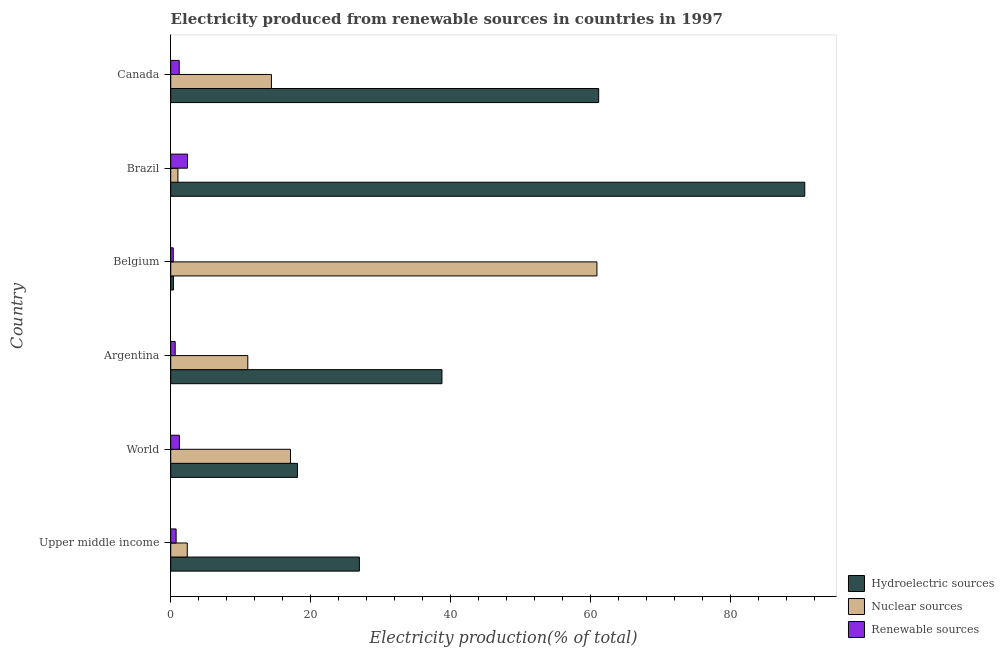How many groups of bars are there?
Offer a terse response. 6. Are the number of bars on each tick of the Y-axis equal?
Keep it short and to the point. Yes. How many bars are there on the 3rd tick from the bottom?
Ensure brevity in your answer.  3. What is the percentage of electricity produced by nuclear sources in Belgium?
Give a very brief answer. 60.89. Across all countries, what is the maximum percentage of electricity produced by renewable sources?
Give a very brief answer. 2.4. Across all countries, what is the minimum percentage of electricity produced by renewable sources?
Your answer should be very brief. 0.36. In which country was the percentage of electricity produced by hydroelectric sources minimum?
Your answer should be very brief. Belgium. What is the total percentage of electricity produced by nuclear sources in the graph?
Make the answer very short. 106.79. What is the difference between the percentage of electricity produced by nuclear sources in Canada and that in World?
Give a very brief answer. -2.72. What is the difference between the percentage of electricity produced by nuclear sources in World and the percentage of electricity produced by renewable sources in Brazil?
Keep it short and to the point. 14.71. What is the average percentage of electricity produced by hydroelectric sources per country?
Give a very brief answer. 39.32. What is the difference between the percentage of electricity produced by nuclear sources and percentage of electricity produced by renewable sources in Brazil?
Offer a terse response. -1.37. Is the percentage of electricity produced by renewable sources in Upper middle income less than that in World?
Offer a terse response. Yes. What is the difference between the highest and the second highest percentage of electricity produced by nuclear sources?
Make the answer very short. 43.78. What is the difference between the highest and the lowest percentage of electricity produced by nuclear sources?
Provide a short and direct response. 59.86. Is the sum of the percentage of electricity produced by hydroelectric sources in Argentina and Belgium greater than the maximum percentage of electricity produced by renewable sources across all countries?
Keep it short and to the point. Yes. What does the 1st bar from the top in Canada represents?
Make the answer very short. Renewable sources. What does the 1st bar from the bottom in World represents?
Offer a very short reply. Hydroelectric sources. How many bars are there?
Your answer should be compact. 18. Are all the bars in the graph horizontal?
Your answer should be very brief. Yes. How many countries are there in the graph?
Offer a very short reply. 6. Where does the legend appear in the graph?
Your answer should be compact. Bottom right. How many legend labels are there?
Your response must be concise. 3. How are the legend labels stacked?
Provide a succinct answer. Vertical. What is the title of the graph?
Ensure brevity in your answer.  Electricity produced from renewable sources in countries in 1997. What is the label or title of the Y-axis?
Your answer should be very brief. Country. What is the Electricity production(% of total) of Hydroelectric sources in Upper middle income?
Offer a very short reply. 26.95. What is the Electricity production(% of total) in Nuclear sources in Upper middle income?
Your answer should be compact. 2.36. What is the Electricity production(% of total) of Renewable sources in Upper middle income?
Your answer should be compact. 0.77. What is the Electricity production(% of total) in Hydroelectric sources in World?
Your answer should be very brief. 18.11. What is the Electricity production(% of total) of Nuclear sources in World?
Keep it short and to the point. 17.11. What is the Electricity production(% of total) of Renewable sources in World?
Your answer should be very brief. 1.24. What is the Electricity production(% of total) of Hydroelectric sources in Argentina?
Offer a terse response. 38.75. What is the Electricity production(% of total) in Nuclear sources in Argentina?
Your response must be concise. 11.01. What is the Electricity production(% of total) of Renewable sources in Argentina?
Your answer should be very brief. 0.64. What is the Electricity production(% of total) of Hydroelectric sources in Belgium?
Give a very brief answer. 0.39. What is the Electricity production(% of total) in Nuclear sources in Belgium?
Ensure brevity in your answer.  60.89. What is the Electricity production(% of total) in Renewable sources in Belgium?
Provide a short and direct response. 0.36. What is the Electricity production(% of total) of Hydroelectric sources in Brazil?
Give a very brief answer. 90.58. What is the Electricity production(% of total) in Nuclear sources in Brazil?
Keep it short and to the point. 1.03. What is the Electricity production(% of total) in Renewable sources in Brazil?
Your answer should be very brief. 2.4. What is the Electricity production(% of total) in Hydroelectric sources in Canada?
Your answer should be very brief. 61.14. What is the Electricity production(% of total) of Nuclear sources in Canada?
Your response must be concise. 14.39. What is the Electricity production(% of total) of Renewable sources in Canada?
Offer a very short reply. 1.21. Across all countries, what is the maximum Electricity production(% of total) in Hydroelectric sources?
Your answer should be compact. 90.58. Across all countries, what is the maximum Electricity production(% of total) of Nuclear sources?
Provide a succinct answer. 60.89. Across all countries, what is the maximum Electricity production(% of total) of Renewable sources?
Provide a short and direct response. 2.4. Across all countries, what is the minimum Electricity production(% of total) of Hydroelectric sources?
Your response must be concise. 0.39. Across all countries, what is the minimum Electricity production(% of total) of Nuclear sources?
Keep it short and to the point. 1.03. Across all countries, what is the minimum Electricity production(% of total) in Renewable sources?
Keep it short and to the point. 0.36. What is the total Electricity production(% of total) of Hydroelectric sources in the graph?
Provide a short and direct response. 235.92. What is the total Electricity production(% of total) of Nuclear sources in the graph?
Your answer should be compact. 106.79. What is the total Electricity production(% of total) in Renewable sources in the graph?
Your answer should be very brief. 6.62. What is the difference between the Electricity production(% of total) in Hydroelectric sources in Upper middle income and that in World?
Your answer should be compact. 8.85. What is the difference between the Electricity production(% of total) in Nuclear sources in Upper middle income and that in World?
Provide a succinct answer. -14.74. What is the difference between the Electricity production(% of total) in Renewable sources in Upper middle income and that in World?
Offer a terse response. -0.47. What is the difference between the Electricity production(% of total) in Hydroelectric sources in Upper middle income and that in Argentina?
Give a very brief answer. -11.8. What is the difference between the Electricity production(% of total) in Nuclear sources in Upper middle income and that in Argentina?
Your answer should be very brief. -8.65. What is the difference between the Electricity production(% of total) of Renewable sources in Upper middle income and that in Argentina?
Offer a terse response. 0.13. What is the difference between the Electricity production(% of total) of Hydroelectric sources in Upper middle income and that in Belgium?
Make the answer very short. 26.56. What is the difference between the Electricity production(% of total) in Nuclear sources in Upper middle income and that in Belgium?
Your response must be concise. -58.52. What is the difference between the Electricity production(% of total) of Renewable sources in Upper middle income and that in Belgium?
Ensure brevity in your answer.  0.41. What is the difference between the Electricity production(% of total) of Hydroelectric sources in Upper middle income and that in Brazil?
Provide a short and direct response. -63.63. What is the difference between the Electricity production(% of total) in Nuclear sources in Upper middle income and that in Brazil?
Give a very brief answer. 1.34. What is the difference between the Electricity production(% of total) of Renewable sources in Upper middle income and that in Brazil?
Ensure brevity in your answer.  -1.63. What is the difference between the Electricity production(% of total) in Hydroelectric sources in Upper middle income and that in Canada?
Give a very brief answer. -34.19. What is the difference between the Electricity production(% of total) of Nuclear sources in Upper middle income and that in Canada?
Make the answer very short. -12.02. What is the difference between the Electricity production(% of total) of Renewable sources in Upper middle income and that in Canada?
Offer a very short reply. -0.44. What is the difference between the Electricity production(% of total) of Hydroelectric sources in World and that in Argentina?
Offer a very short reply. -20.64. What is the difference between the Electricity production(% of total) of Nuclear sources in World and that in Argentina?
Provide a short and direct response. 6.1. What is the difference between the Electricity production(% of total) in Renewable sources in World and that in Argentina?
Offer a terse response. 0.6. What is the difference between the Electricity production(% of total) in Hydroelectric sources in World and that in Belgium?
Keep it short and to the point. 17.71. What is the difference between the Electricity production(% of total) of Nuclear sources in World and that in Belgium?
Your answer should be compact. -43.78. What is the difference between the Electricity production(% of total) of Renewable sources in World and that in Belgium?
Make the answer very short. 0.88. What is the difference between the Electricity production(% of total) in Hydroelectric sources in World and that in Brazil?
Offer a terse response. -72.48. What is the difference between the Electricity production(% of total) of Nuclear sources in World and that in Brazil?
Provide a short and direct response. 16.08. What is the difference between the Electricity production(% of total) of Renewable sources in World and that in Brazil?
Your answer should be compact. -1.16. What is the difference between the Electricity production(% of total) of Hydroelectric sources in World and that in Canada?
Give a very brief answer. -43.03. What is the difference between the Electricity production(% of total) in Nuclear sources in World and that in Canada?
Keep it short and to the point. 2.72. What is the difference between the Electricity production(% of total) of Renewable sources in World and that in Canada?
Give a very brief answer. 0.03. What is the difference between the Electricity production(% of total) of Hydroelectric sources in Argentina and that in Belgium?
Your response must be concise. 38.36. What is the difference between the Electricity production(% of total) of Nuclear sources in Argentina and that in Belgium?
Your answer should be compact. -49.88. What is the difference between the Electricity production(% of total) in Renewable sources in Argentina and that in Belgium?
Ensure brevity in your answer.  0.27. What is the difference between the Electricity production(% of total) in Hydroelectric sources in Argentina and that in Brazil?
Your response must be concise. -51.83. What is the difference between the Electricity production(% of total) in Nuclear sources in Argentina and that in Brazil?
Your response must be concise. 9.98. What is the difference between the Electricity production(% of total) of Renewable sources in Argentina and that in Brazil?
Provide a short and direct response. -1.76. What is the difference between the Electricity production(% of total) of Hydroelectric sources in Argentina and that in Canada?
Your response must be concise. -22.39. What is the difference between the Electricity production(% of total) of Nuclear sources in Argentina and that in Canada?
Give a very brief answer. -3.38. What is the difference between the Electricity production(% of total) of Renewable sources in Argentina and that in Canada?
Make the answer very short. -0.57. What is the difference between the Electricity production(% of total) of Hydroelectric sources in Belgium and that in Brazil?
Your response must be concise. -90.19. What is the difference between the Electricity production(% of total) in Nuclear sources in Belgium and that in Brazil?
Make the answer very short. 59.86. What is the difference between the Electricity production(% of total) in Renewable sources in Belgium and that in Brazil?
Offer a very short reply. -2.03. What is the difference between the Electricity production(% of total) of Hydroelectric sources in Belgium and that in Canada?
Offer a very short reply. -60.75. What is the difference between the Electricity production(% of total) of Nuclear sources in Belgium and that in Canada?
Keep it short and to the point. 46.5. What is the difference between the Electricity production(% of total) of Renewable sources in Belgium and that in Canada?
Ensure brevity in your answer.  -0.85. What is the difference between the Electricity production(% of total) in Hydroelectric sources in Brazil and that in Canada?
Your answer should be compact. 29.44. What is the difference between the Electricity production(% of total) of Nuclear sources in Brazil and that in Canada?
Keep it short and to the point. -13.36. What is the difference between the Electricity production(% of total) in Renewable sources in Brazil and that in Canada?
Make the answer very short. 1.19. What is the difference between the Electricity production(% of total) of Hydroelectric sources in Upper middle income and the Electricity production(% of total) of Nuclear sources in World?
Offer a very short reply. 9.85. What is the difference between the Electricity production(% of total) of Hydroelectric sources in Upper middle income and the Electricity production(% of total) of Renewable sources in World?
Give a very brief answer. 25.71. What is the difference between the Electricity production(% of total) of Nuclear sources in Upper middle income and the Electricity production(% of total) of Renewable sources in World?
Your response must be concise. 1.12. What is the difference between the Electricity production(% of total) in Hydroelectric sources in Upper middle income and the Electricity production(% of total) in Nuclear sources in Argentina?
Offer a very short reply. 15.94. What is the difference between the Electricity production(% of total) of Hydroelectric sources in Upper middle income and the Electricity production(% of total) of Renewable sources in Argentina?
Give a very brief answer. 26.31. What is the difference between the Electricity production(% of total) in Nuclear sources in Upper middle income and the Electricity production(% of total) in Renewable sources in Argentina?
Make the answer very short. 1.73. What is the difference between the Electricity production(% of total) in Hydroelectric sources in Upper middle income and the Electricity production(% of total) in Nuclear sources in Belgium?
Make the answer very short. -33.94. What is the difference between the Electricity production(% of total) in Hydroelectric sources in Upper middle income and the Electricity production(% of total) in Renewable sources in Belgium?
Your answer should be compact. 26.59. What is the difference between the Electricity production(% of total) of Nuclear sources in Upper middle income and the Electricity production(% of total) of Renewable sources in Belgium?
Provide a short and direct response. 2. What is the difference between the Electricity production(% of total) in Hydroelectric sources in Upper middle income and the Electricity production(% of total) in Nuclear sources in Brazil?
Keep it short and to the point. 25.92. What is the difference between the Electricity production(% of total) in Hydroelectric sources in Upper middle income and the Electricity production(% of total) in Renewable sources in Brazil?
Your response must be concise. 24.56. What is the difference between the Electricity production(% of total) in Nuclear sources in Upper middle income and the Electricity production(% of total) in Renewable sources in Brazil?
Your answer should be compact. -0.03. What is the difference between the Electricity production(% of total) of Hydroelectric sources in Upper middle income and the Electricity production(% of total) of Nuclear sources in Canada?
Give a very brief answer. 12.56. What is the difference between the Electricity production(% of total) of Hydroelectric sources in Upper middle income and the Electricity production(% of total) of Renewable sources in Canada?
Your answer should be compact. 25.74. What is the difference between the Electricity production(% of total) of Nuclear sources in Upper middle income and the Electricity production(% of total) of Renewable sources in Canada?
Keep it short and to the point. 1.15. What is the difference between the Electricity production(% of total) in Hydroelectric sources in World and the Electricity production(% of total) in Nuclear sources in Argentina?
Your answer should be compact. 7.09. What is the difference between the Electricity production(% of total) in Hydroelectric sources in World and the Electricity production(% of total) in Renewable sources in Argentina?
Offer a very short reply. 17.47. What is the difference between the Electricity production(% of total) in Nuclear sources in World and the Electricity production(% of total) in Renewable sources in Argentina?
Your answer should be very brief. 16.47. What is the difference between the Electricity production(% of total) in Hydroelectric sources in World and the Electricity production(% of total) in Nuclear sources in Belgium?
Keep it short and to the point. -42.78. What is the difference between the Electricity production(% of total) of Hydroelectric sources in World and the Electricity production(% of total) of Renewable sources in Belgium?
Offer a very short reply. 17.74. What is the difference between the Electricity production(% of total) in Nuclear sources in World and the Electricity production(% of total) in Renewable sources in Belgium?
Give a very brief answer. 16.74. What is the difference between the Electricity production(% of total) in Hydroelectric sources in World and the Electricity production(% of total) in Nuclear sources in Brazil?
Ensure brevity in your answer.  17.08. What is the difference between the Electricity production(% of total) of Hydroelectric sources in World and the Electricity production(% of total) of Renewable sources in Brazil?
Your response must be concise. 15.71. What is the difference between the Electricity production(% of total) in Nuclear sources in World and the Electricity production(% of total) in Renewable sources in Brazil?
Give a very brief answer. 14.71. What is the difference between the Electricity production(% of total) of Hydroelectric sources in World and the Electricity production(% of total) of Nuclear sources in Canada?
Offer a very short reply. 3.72. What is the difference between the Electricity production(% of total) of Hydroelectric sources in World and the Electricity production(% of total) of Renewable sources in Canada?
Provide a short and direct response. 16.89. What is the difference between the Electricity production(% of total) of Nuclear sources in World and the Electricity production(% of total) of Renewable sources in Canada?
Ensure brevity in your answer.  15.9. What is the difference between the Electricity production(% of total) of Hydroelectric sources in Argentina and the Electricity production(% of total) of Nuclear sources in Belgium?
Provide a succinct answer. -22.14. What is the difference between the Electricity production(% of total) in Hydroelectric sources in Argentina and the Electricity production(% of total) in Renewable sources in Belgium?
Make the answer very short. 38.39. What is the difference between the Electricity production(% of total) in Nuclear sources in Argentina and the Electricity production(% of total) in Renewable sources in Belgium?
Ensure brevity in your answer.  10.65. What is the difference between the Electricity production(% of total) in Hydroelectric sources in Argentina and the Electricity production(% of total) in Nuclear sources in Brazil?
Your response must be concise. 37.72. What is the difference between the Electricity production(% of total) in Hydroelectric sources in Argentina and the Electricity production(% of total) in Renewable sources in Brazil?
Offer a very short reply. 36.35. What is the difference between the Electricity production(% of total) in Nuclear sources in Argentina and the Electricity production(% of total) in Renewable sources in Brazil?
Your answer should be very brief. 8.61. What is the difference between the Electricity production(% of total) in Hydroelectric sources in Argentina and the Electricity production(% of total) in Nuclear sources in Canada?
Your answer should be compact. 24.36. What is the difference between the Electricity production(% of total) of Hydroelectric sources in Argentina and the Electricity production(% of total) of Renewable sources in Canada?
Your answer should be very brief. 37.54. What is the difference between the Electricity production(% of total) in Nuclear sources in Argentina and the Electricity production(% of total) in Renewable sources in Canada?
Provide a succinct answer. 9.8. What is the difference between the Electricity production(% of total) in Hydroelectric sources in Belgium and the Electricity production(% of total) in Nuclear sources in Brazil?
Make the answer very short. -0.64. What is the difference between the Electricity production(% of total) in Hydroelectric sources in Belgium and the Electricity production(% of total) in Renewable sources in Brazil?
Ensure brevity in your answer.  -2.01. What is the difference between the Electricity production(% of total) in Nuclear sources in Belgium and the Electricity production(% of total) in Renewable sources in Brazil?
Your answer should be compact. 58.49. What is the difference between the Electricity production(% of total) of Hydroelectric sources in Belgium and the Electricity production(% of total) of Nuclear sources in Canada?
Keep it short and to the point. -14. What is the difference between the Electricity production(% of total) of Hydroelectric sources in Belgium and the Electricity production(% of total) of Renewable sources in Canada?
Your answer should be very brief. -0.82. What is the difference between the Electricity production(% of total) of Nuclear sources in Belgium and the Electricity production(% of total) of Renewable sources in Canada?
Ensure brevity in your answer.  59.68. What is the difference between the Electricity production(% of total) in Hydroelectric sources in Brazil and the Electricity production(% of total) in Nuclear sources in Canada?
Offer a very short reply. 76.19. What is the difference between the Electricity production(% of total) of Hydroelectric sources in Brazil and the Electricity production(% of total) of Renewable sources in Canada?
Your answer should be compact. 89.37. What is the difference between the Electricity production(% of total) in Nuclear sources in Brazil and the Electricity production(% of total) in Renewable sources in Canada?
Give a very brief answer. -0.18. What is the average Electricity production(% of total) in Hydroelectric sources per country?
Give a very brief answer. 39.32. What is the average Electricity production(% of total) of Nuclear sources per country?
Offer a very short reply. 17.8. What is the average Electricity production(% of total) in Renewable sources per country?
Offer a very short reply. 1.1. What is the difference between the Electricity production(% of total) in Hydroelectric sources and Electricity production(% of total) in Nuclear sources in Upper middle income?
Ensure brevity in your answer.  24.59. What is the difference between the Electricity production(% of total) of Hydroelectric sources and Electricity production(% of total) of Renewable sources in Upper middle income?
Offer a terse response. 26.18. What is the difference between the Electricity production(% of total) in Nuclear sources and Electricity production(% of total) in Renewable sources in Upper middle income?
Provide a short and direct response. 1.59. What is the difference between the Electricity production(% of total) in Hydroelectric sources and Electricity production(% of total) in Nuclear sources in World?
Your answer should be very brief. 1. What is the difference between the Electricity production(% of total) of Hydroelectric sources and Electricity production(% of total) of Renewable sources in World?
Provide a short and direct response. 16.87. What is the difference between the Electricity production(% of total) in Nuclear sources and Electricity production(% of total) in Renewable sources in World?
Offer a terse response. 15.87. What is the difference between the Electricity production(% of total) in Hydroelectric sources and Electricity production(% of total) in Nuclear sources in Argentina?
Your answer should be compact. 27.74. What is the difference between the Electricity production(% of total) in Hydroelectric sources and Electricity production(% of total) in Renewable sources in Argentina?
Your answer should be compact. 38.11. What is the difference between the Electricity production(% of total) of Nuclear sources and Electricity production(% of total) of Renewable sources in Argentina?
Offer a terse response. 10.37. What is the difference between the Electricity production(% of total) in Hydroelectric sources and Electricity production(% of total) in Nuclear sources in Belgium?
Ensure brevity in your answer.  -60.5. What is the difference between the Electricity production(% of total) of Hydroelectric sources and Electricity production(% of total) of Renewable sources in Belgium?
Offer a very short reply. 0.03. What is the difference between the Electricity production(% of total) in Nuclear sources and Electricity production(% of total) in Renewable sources in Belgium?
Your response must be concise. 60.52. What is the difference between the Electricity production(% of total) of Hydroelectric sources and Electricity production(% of total) of Nuclear sources in Brazil?
Your answer should be compact. 89.55. What is the difference between the Electricity production(% of total) in Hydroelectric sources and Electricity production(% of total) in Renewable sources in Brazil?
Your response must be concise. 88.18. What is the difference between the Electricity production(% of total) in Nuclear sources and Electricity production(% of total) in Renewable sources in Brazil?
Provide a succinct answer. -1.37. What is the difference between the Electricity production(% of total) of Hydroelectric sources and Electricity production(% of total) of Nuclear sources in Canada?
Ensure brevity in your answer.  46.75. What is the difference between the Electricity production(% of total) in Hydroelectric sources and Electricity production(% of total) in Renewable sources in Canada?
Keep it short and to the point. 59.93. What is the difference between the Electricity production(% of total) in Nuclear sources and Electricity production(% of total) in Renewable sources in Canada?
Keep it short and to the point. 13.18. What is the ratio of the Electricity production(% of total) in Hydroelectric sources in Upper middle income to that in World?
Provide a short and direct response. 1.49. What is the ratio of the Electricity production(% of total) in Nuclear sources in Upper middle income to that in World?
Your response must be concise. 0.14. What is the ratio of the Electricity production(% of total) of Renewable sources in Upper middle income to that in World?
Ensure brevity in your answer.  0.62. What is the ratio of the Electricity production(% of total) in Hydroelectric sources in Upper middle income to that in Argentina?
Your response must be concise. 0.7. What is the ratio of the Electricity production(% of total) of Nuclear sources in Upper middle income to that in Argentina?
Your response must be concise. 0.21. What is the ratio of the Electricity production(% of total) of Renewable sources in Upper middle income to that in Argentina?
Keep it short and to the point. 1.21. What is the ratio of the Electricity production(% of total) in Hydroelectric sources in Upper middle income to that in Belgium?
Your answer should be very brief. 68.8. What is the ratio of the Electricity production(% of total) of Nuclear sources in Upper middle income to that in Belgium?
Offer a terse response. 0.04. What is the ratio of the Electricity production(% of total) in Renewable sources in Upper middle income to that in Belgium?
Make the answer very short. 2.12. What is the ratio of the Electricity production(% of total) in Hydroelectric sources in Upper middle income to that in Brazil?
Provide a succinct answer. 0.3. What is the ratio of the Electricity production(% of total) of Nuclear sources in Upper middle income to that in Brazil?
Your answer should be compact. 2.3. What is the ratio of the Electricity production(% of total) in Renewable sources in Upper middle income to that in Brazil?
Make the answer very short. 0.32. What is the ratio of the Electricity production(% of total) of Hydroelectric sources in Upper middle income to that in Canada?
Provide a succinct answer. 0.44. What is the ratio of the Electricity production(% of total) in Nuclear sources in Upper middle income to that in Canada?
Provide a succinct answer. 0.16. What is the ratio of the Electricity production(% of total) in Renewable sources in Upper middle income to that in Canada?
Provide a short and direct response. 0.64. What is the ratio of the Electricity production(% of total) in Hydroelectric sources in World to that in Argentina?
Your response must be concise. 0.47. What is the ratio of the Electricity production(% of total) in Nuclear sources in World to that in Argentina?
Your response must be concise. 1.55. What is the ratio of the Electricity production(% of total) in Renewable sources in World to that in Argentina?
Offer a very short reply. 1.94. What is the ratio of the Electricity production(% of total) in Hydroelectric sources in World to that in Belgium?
Keep it short and to the point. 46.22. What is the ratio of the Electricity production(% of total) of Nuclear sources in World to that in Belgium?
Give a very brief answer. 0.28. What is the ratio of the Electricity production(% of total) in Renewable sources in World to that in Belgium?
Make the answer very short. 3.41. What is the ratio of the Electricity production(% of total) in Hydroelectric sources in World to that in Brazil?
Provide a short and direct response. 0.2. What is the ratio of the Electricity production(% of total) of Nuclear sources in World to that in Brazil?
Your answer should be compact. 16.63. What is the ratio of the Electricity production(% of total) in Renewable sources in World to that in Brazil?
Make the answer very short. 0.52. What is the ratio of the Electricity production(% of total) in Hydroelectric sources in World to that in Canada?
Give a very brief answer. 0.3. What is the ratio of the Electricity production(% of total) in Nuclear sources in World to that in Canada?
Your response must be concise. 1.19. What is the ratio of the Electricity production(% of total) of Renewable sources in World to that in Canada?
Give a very brief answer. 1.02. What is the ratio of the Electricity production(% of total) in Hydroelectric sources in Argentina to that in Belgium?
Keep it short and to the point. 98.92. What is the ratio of the Electricity production(% of total) of Nuclear sources in Argentina to that in Belgium?
Make the answer very short. 0.18. What is the ratio of the Electricity production(% of total) in Renewable sources in Argentina to that in Belgium?
Your answer should be very brief. 1.75. What is the ratio of the Electricity production(% of total) of Hydroelectric sources in Argentina to that in Brazil?
Provide a succinct answer. 0.43. What is the ratio of the Electricity production(% of total) in Nuclear sources in Argentina to that in Brazil?
Ensure brevity in your answer.  10.7. What is the ratio of the Electricity production(% of total) of Renewable sources in Argentina to that in Brazil?
Offer a very short reply. 0.27. What is the ratio of the Electricity production(% of total) in Hydroelectric sources in Argentina to that in Canada?
Your answer should be very brief. 0.63. What is the ratio of the Electricity production(% of total) in Nuclear sources in Argentina to that in Canada?
Offer a very short reply. 0.77. What is the ratio of the Electricity production(% of total) in Renewable sources in Argentina to that in Canada?
Ensure brevity in your answer.  0.53. What is the ratio of the Electricity production(% of total) of Hydroelectric sources in Belgium to that in Brazil?
Ensure brevity in your answer.  0. What is the ratio of the Electricity production(% of total) in Nuclear sources in Belgium to that in Brazil?
Your answer should be very brief. 59.17. What is the ratio of the Electricity production(% of total) in Renewable sources in Belgium to that in Brazil?
Provide a succinct answer. 0.15. What is the ratio of the Electricity production(% of total) in Hydroelectric sources in Belgium to that in Canada?
Your answer should be very brief. 0.01. What is the ratio of the Electricity production(% of total) of Nuclear sources in Belgium to that in Canada?
Ensure brevity in your answer.  4.23. What is the ratio of the Electricity production(% of total) of Renewable sources in Belgium to that in Canada?
Your answer should be very brief. 0.3. What is the ratio of the Electricity production(% of total) in Hydroelectric sources in Brazil to that in Canada?
Offer a terse response. 1.48. What is the ratio of the Electricity production(% of total) of Nuclear sources in Brazil to that in Canada?
Make the answer very short. 0.07. What is the ratio of the Electricity production(% of total) of Renewable sources in Brazil to that in Canada?
Offer a terse response. 1.98. What is the difference between the highest and the second highest Electricity production(% of total) in Hydroelectric sources?
Ensure brevity in your answer.  29.44. What is the difference between the highest and the second highest Electricity production(% of total) of Nuclear sources?
Ensure brevity in your answer.  43.78. What is the difference between the highest and the second highest Electricity production(% of total) in Renewable sources?
Offer a very short reply. 1.16. What is the difference between the highest and the lowest Electricity production(% of total) of Hydroelectric sources?
Ensure brevity in your answer.  90.19. What is the difference between the highest and the lowest Electricity production(% of total) of Nuclear sources?
Keep it short and to the point. 59.86. What is the difference between the highest and the lowest Electricity production(% of total) in Renewable sources?
Provide a succinct answer. 2.03. 